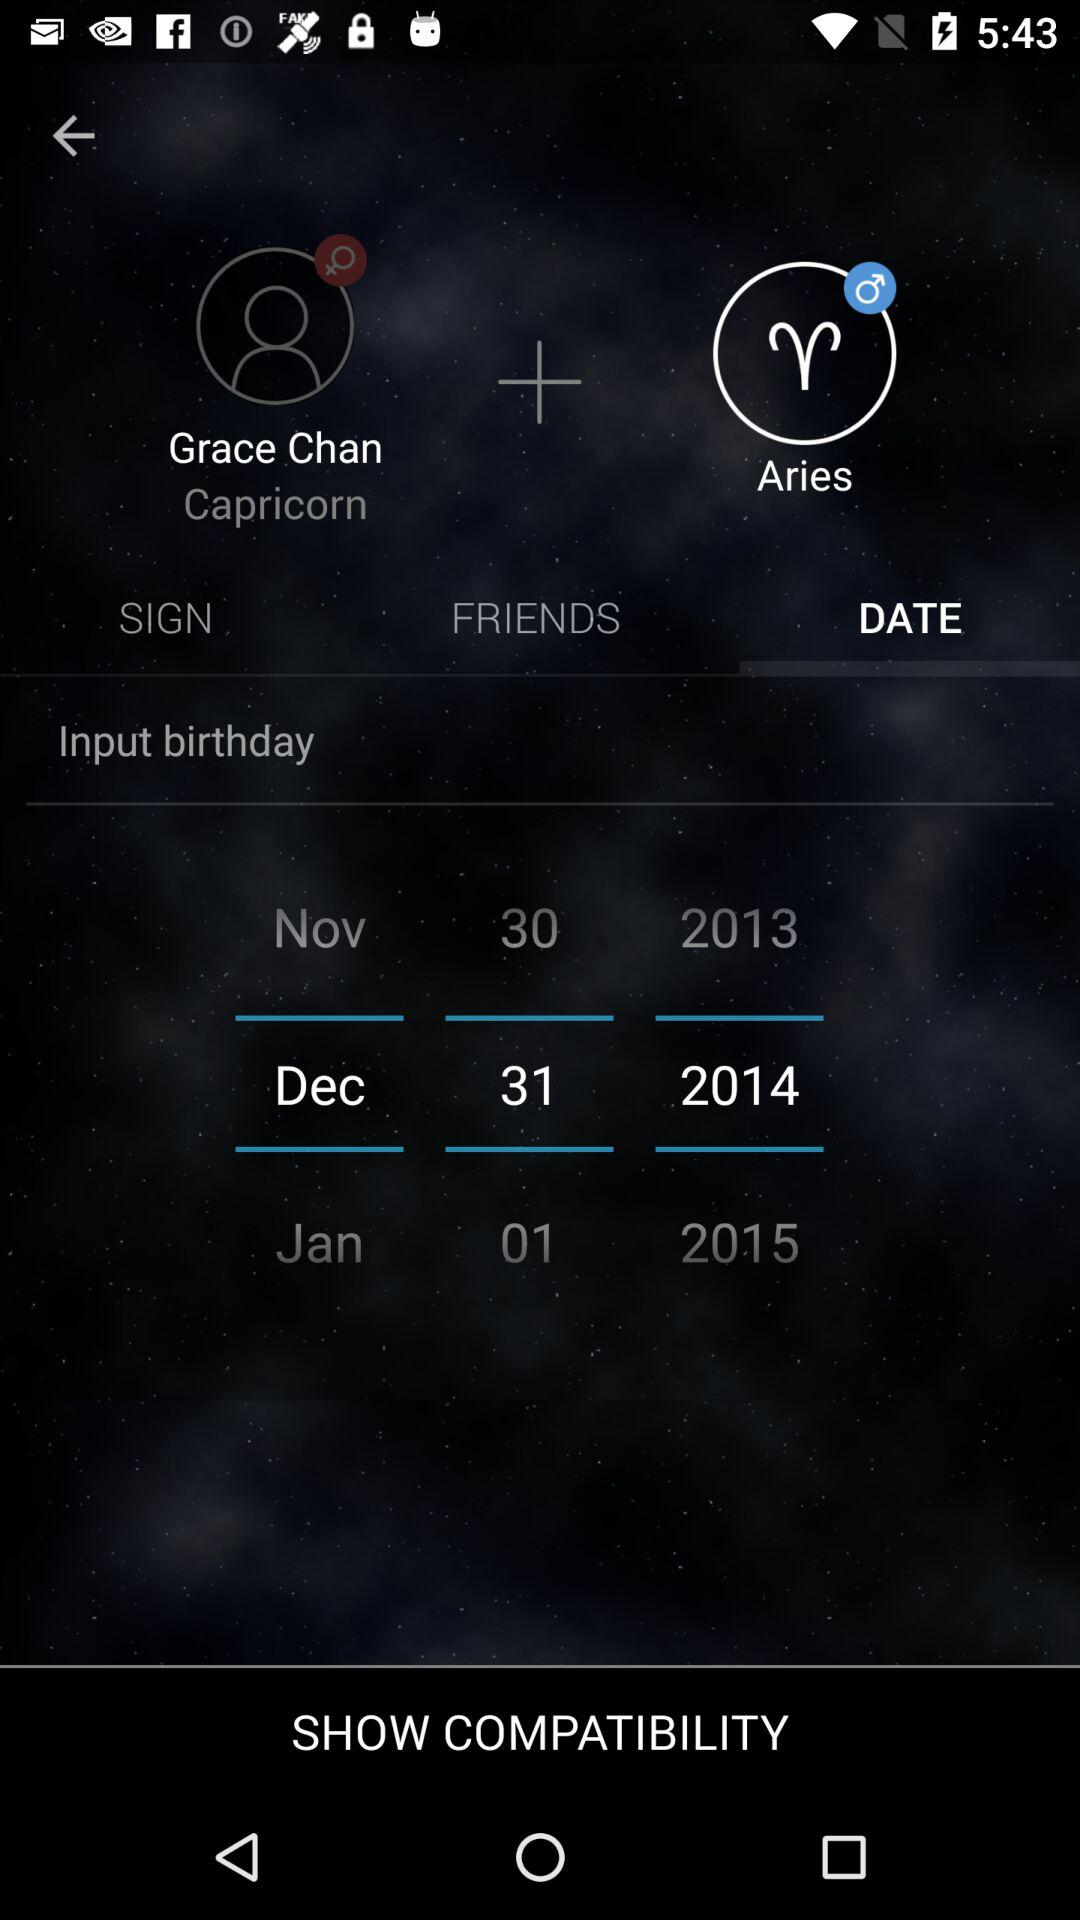What is the name of the user who is an Aries?
When the provided information is insufficient, respond with <no answer>. <no answer> 